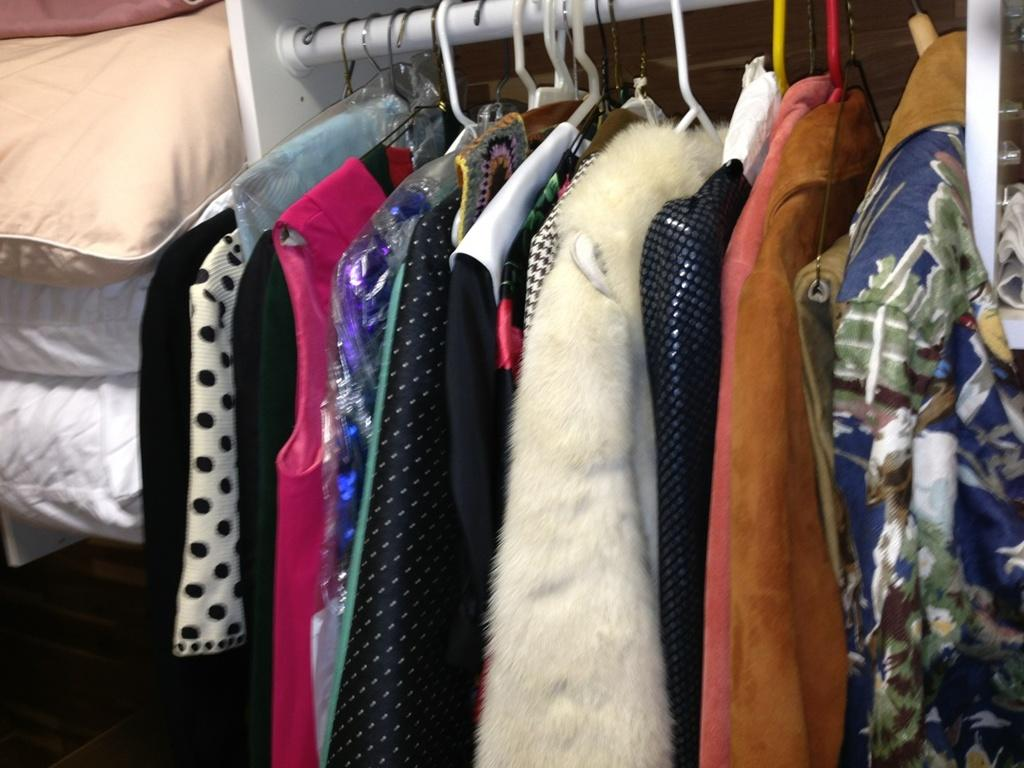What is hanging on the rod in the image? There are clothes on hangers in the image. How are the clothes arranged on the rod? The clothes are hung on a rod. What other items are visible near the clothes? There are quilts beside the clothes. Who said good-bye to the quilts in the image? There is no indication in the image of anyone saying good-bye to the quilts. Is there an uncle present in the image? There is no mention of an uncle or any people in the image. 